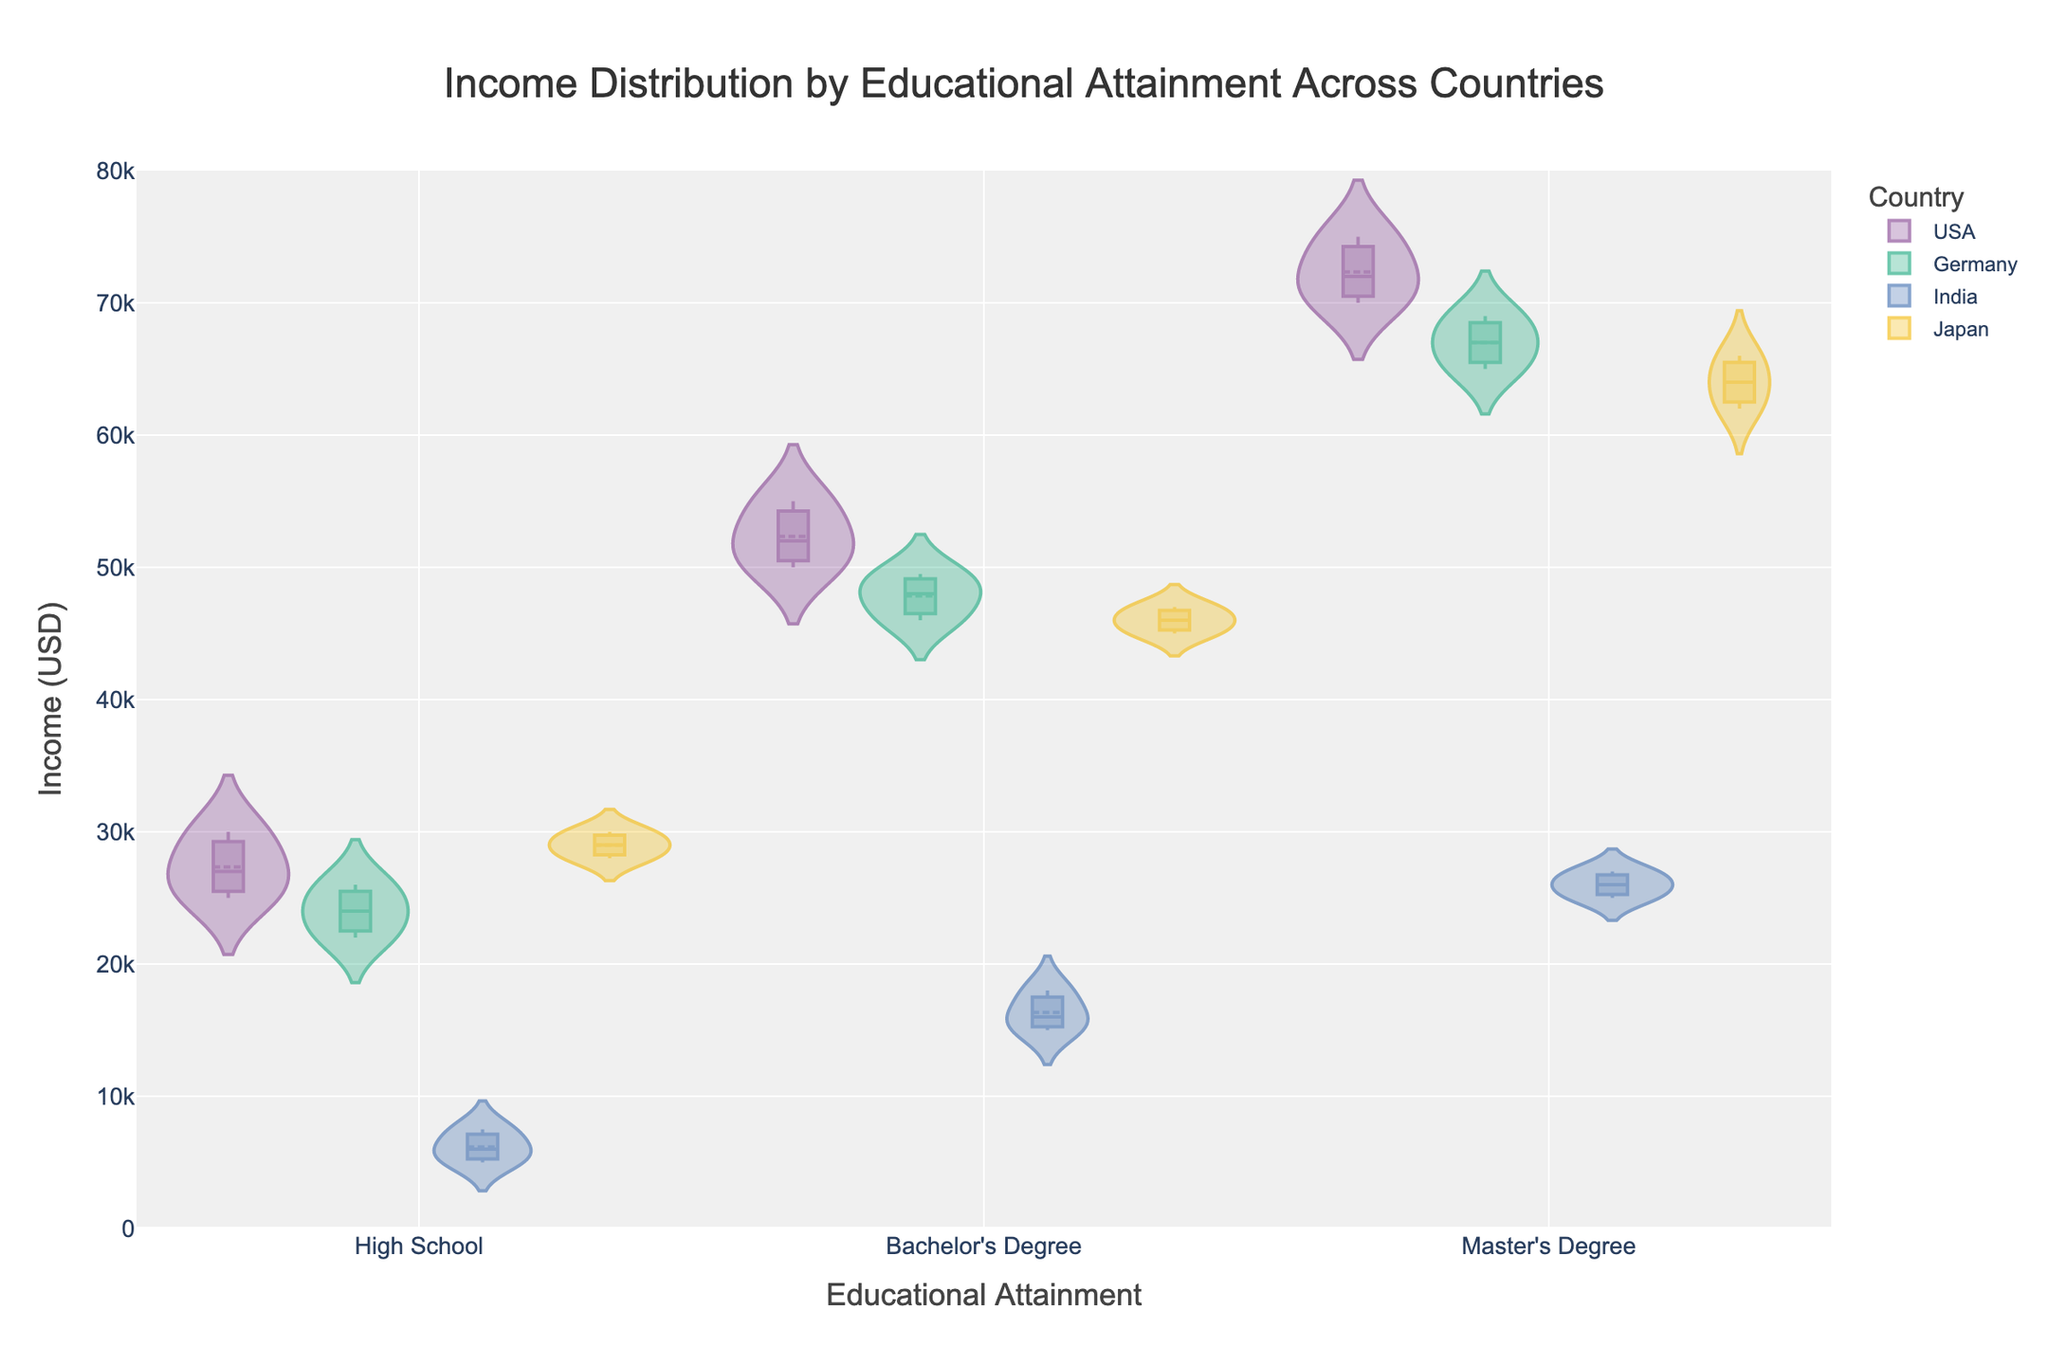What is the title of the figure? The title is usually placed at the top center of the figure, and it provides a summary of the information presented.
Answer: Income Distribution by Educational Attainment Across Countries Which country has the highest median income for Master's Degree holders? To determine the country with the highest median income for Master’s Degree holders, one must identify the box plot within the violin plot for each country and compare the medians, which are indicated by a line inside the box.
Answer: USA How does the income distribution of Bachelor's Degree holders in Japan compare to that in Germany? To compare, examine the violin plots for Bachelor’s Degree holders in both Japan and Germany. Look at the spread of the violin plots and the box plots within them (indicating the interquartile range and median). Assess which has a wider/narrower distribution and if one set of incomes appears higher or lower on average.
Answer: Japan has a narrower distribution, with incomes tightly clustered around the median, while Germany shows a slightly broader range What is the range of income for High School graduates in India? The range can be identified by looking at the spread of the violin plot and the box plot lines for High School graduates in India. Specifically, the distance from the minimum to the maximum value on the y-axis.
Answer: 5000 to 7500 USD Which educational attainment level shows the greatest variation in income within the USA? Find the widest violin plot for different educational attainment levels within the USA, as the width indicates the variation or spread of the data. Also, the box plot's range (from minimum to maximum) within these violins can help assess variation.
Answer: Master's Degree Does Germany or India have a higher median income for Bachelor’s Degree holders? Compare the median lines inside the box plots for Bachelor’s Degree holders in Germany and India. The higher line indicates a higher median income.
Answer: Germany Is there a significant difference in income distributions between Master's Degree holders in Japan and Germany? Examine both the shape of the violin plots and the spread of the box plots for Master's Degree holders in Japan and Germany. Significant differences will be reflected in the width, range, and position of these plots.
Answer: Yes, Japan’s distribution is slightly less variable compared to Germany's What's the general trend observed for income as educational attainment increases across the countries? Look at the y-axis positions of the violin plots as educational attainment increases from High School to Master’s Degree. The overall upward or downward trend indicates if income increases or decreases with educational attainment.
Answer: Income generally increases with higher educational attainment Which country has the lowest median income for High School graduates? Check the median lines within the box plots for High School graduates across all countries and identify the one lowest on the y-axis.
Answer: India 